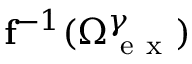Convert formula to latex. <formula><loc_0><loc_0><loc_500><loc_500>f ^ { - 1 } ( \Omega _ { e x } ^ { \gamma } )</formula> 